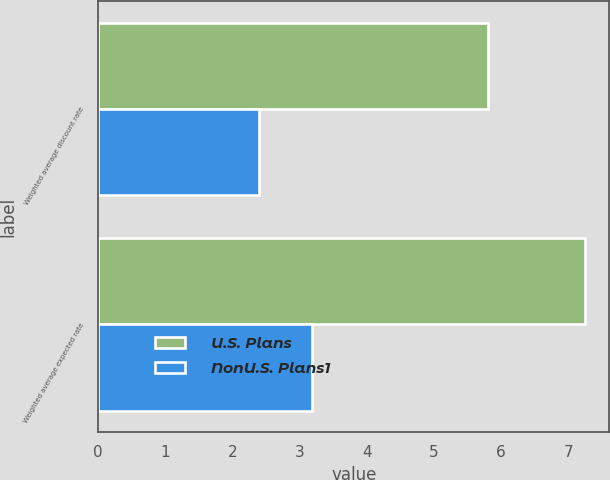Convert chart to OTSL. <chart><loc_0><loc_0><loc_500><loc_500><stacked_bar_chart><ecel><fcel>Weighted average discount rate<fcel>Weighted average expected rate<nl><fcel>U.S. Plans<fcel>5.8<fcel>7.25<nl><fcel>NonU.S. Plans1<fcel>2.4<fcel>3.19<nl></chart> 